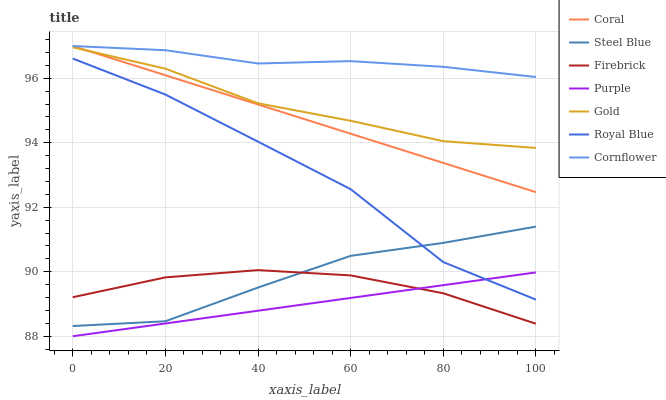Does Gold have the minimum area under the curve?
Answer yes or no. No. Does Gold have the maximum area under the curve?
Answer yes or no. No. Is Gold the smoothest?
Answer yes or no. No. Is Gold the roughest?
Answer yes or no. No. Does Gold have the lowest value?
Answer yes or no. No. Does Gold have the highest value?
Answer yes or no. No. Is Purple less than Coral?
Answer yes or no. Yes. Is Royal Blue greater than Firebrick?
Answer yes or no. Yes. Does Purple intersect Coral?
Answer yes or no. No. 